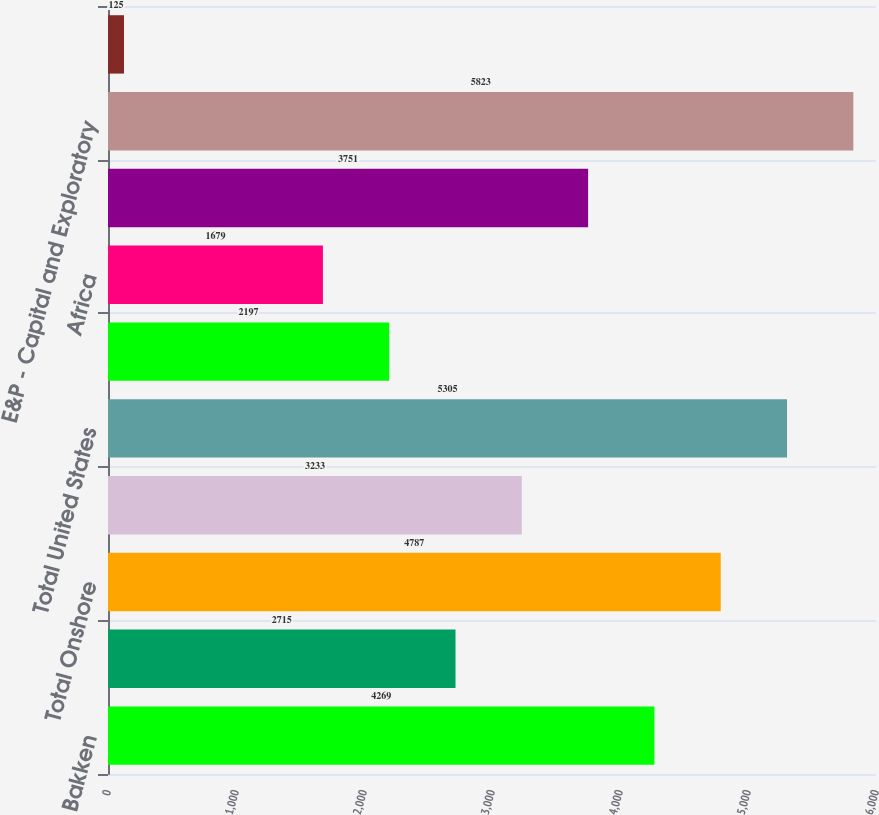Convert chart. <chart><loc_0><loc_0><loc_500><loc_500><bar_chart><fcel>Bakken<fcel>Other Onshore<fcel>Total Onshore<fcel>Offshore<fcel>Total United States<fcel>Europe<fcel>Africa<fcel>Asia and other<fcel>E&P - Capital and Exploratory<fcel>United States<nl><fcel>4269<fcel>2715<fcel>4787<fcel>3233<fcel>5305<fcel>2197<fcel>1679<fcel>3751<fcel>5823<fcel>125<nl></chart> 